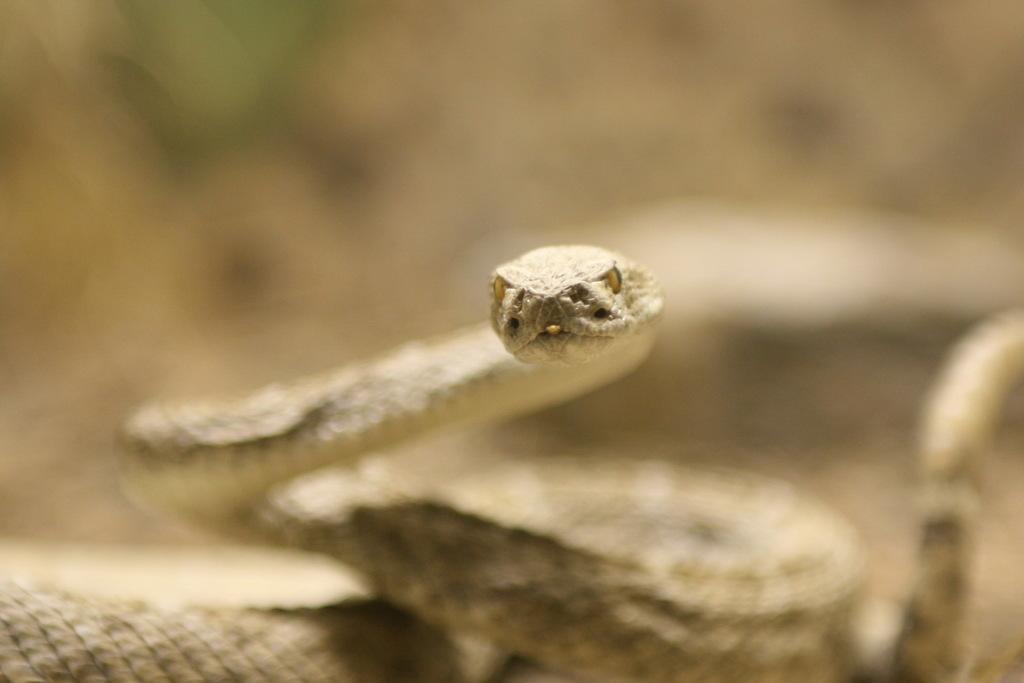What animal is present in the image? There is a snake in the image. What color is the background of the image? The background of the image is blue. What type of wheel can be seen in the image? There is no wheel present in the image; it features a snake and a blue background. What fruit is being offered as an afterthought in the image? There is no fruit or afterthought present in the image; it only features a snake and a blue background. 